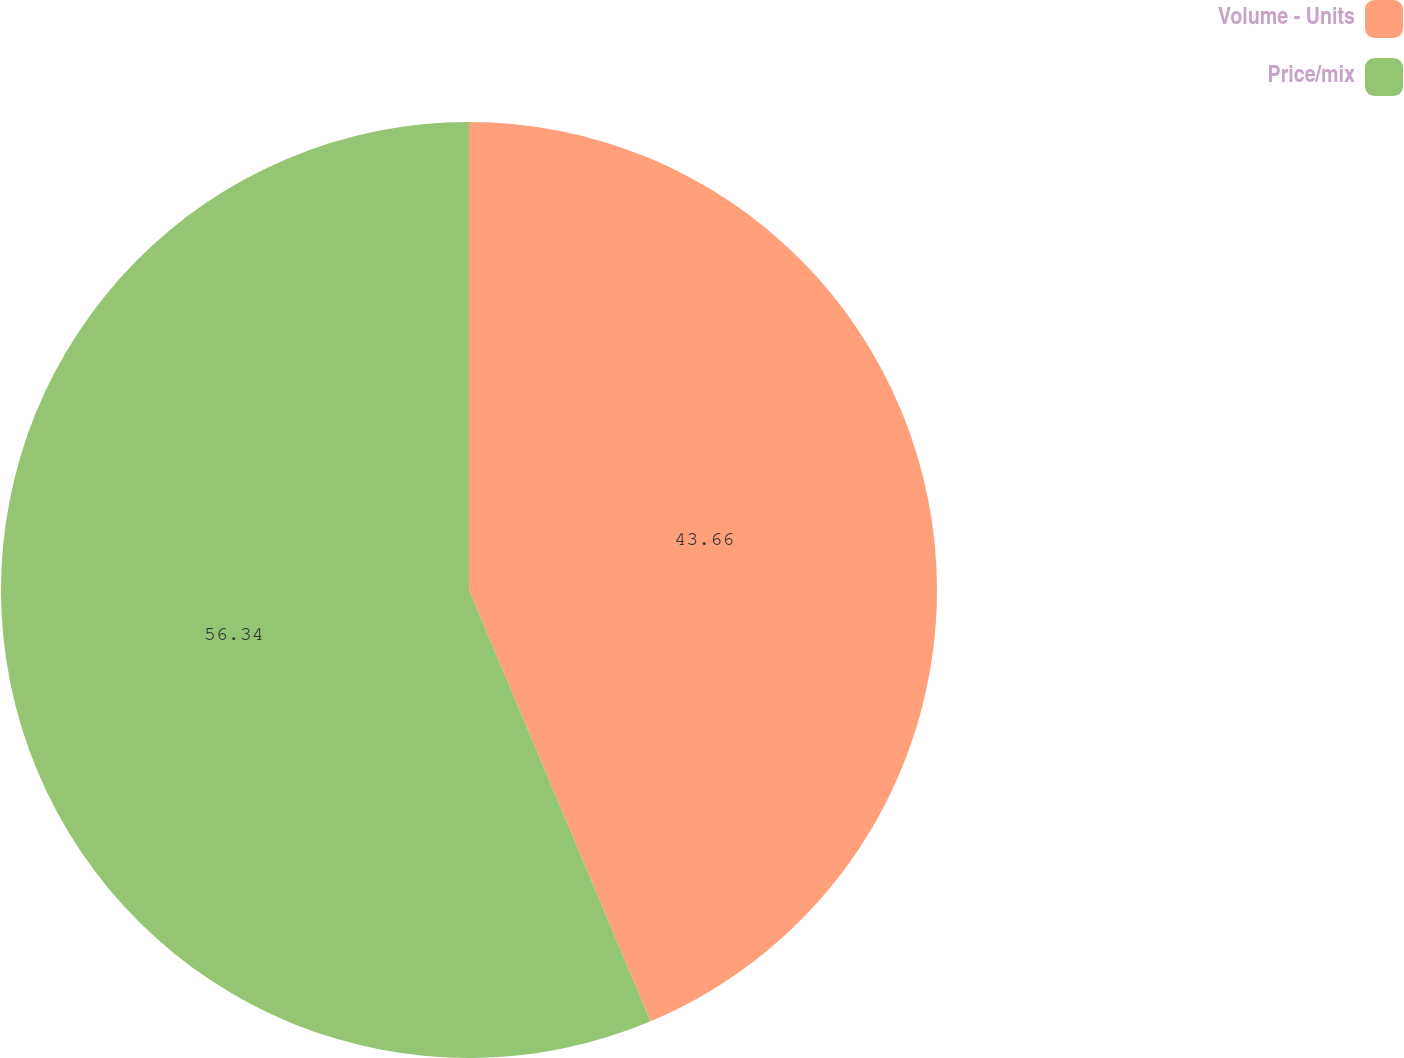<chart> <loc_0><loc_0><loc_500><loc_500><pie_chart><fcel>Volume - Units<fcel>Price/mix<nl><fcel>43.66%<fcel>56.34%<nl></chart> 